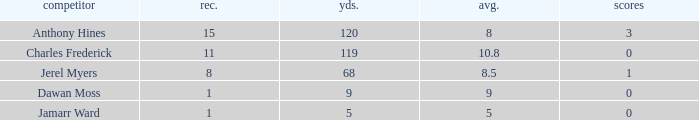What is the total Avg when TDs are 0 and Dawan Moss is a player? 0.0. 